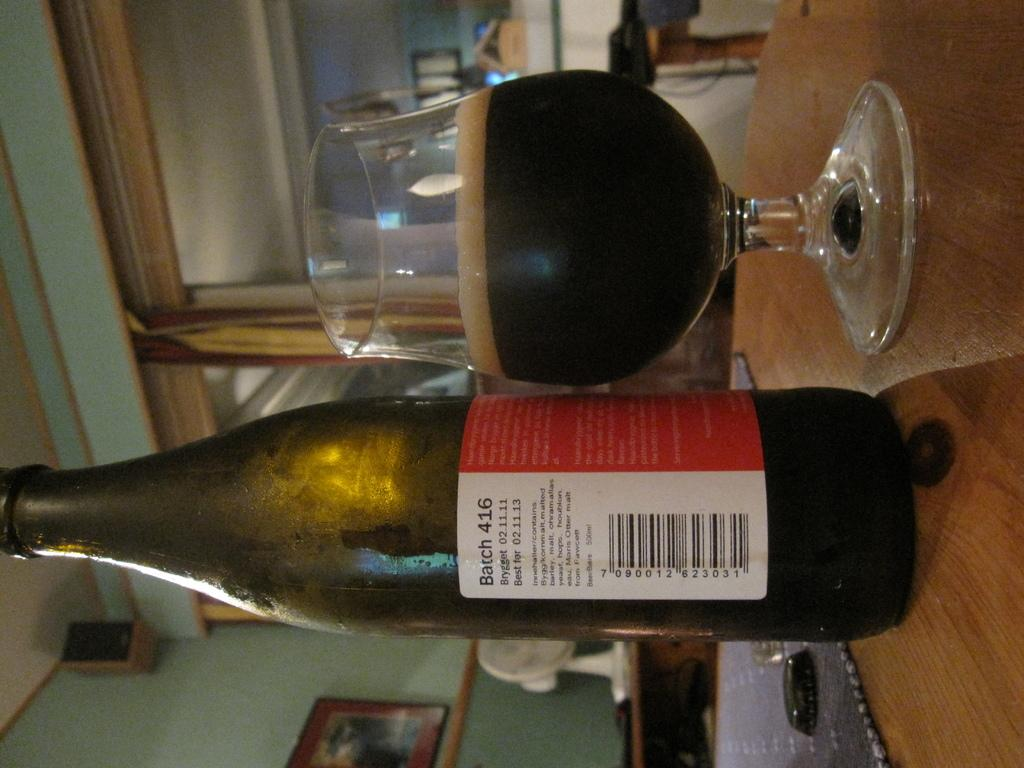<image>
Offer a succinct explanation of the picture presented. the name barch that is written on wine 